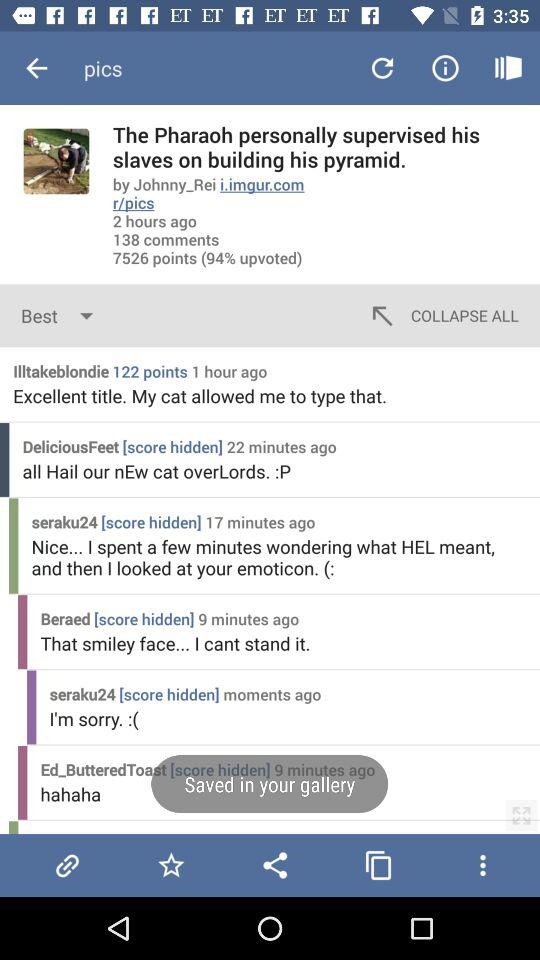How many comments does the post have?
Answer the question using a single word or phrase. 138 